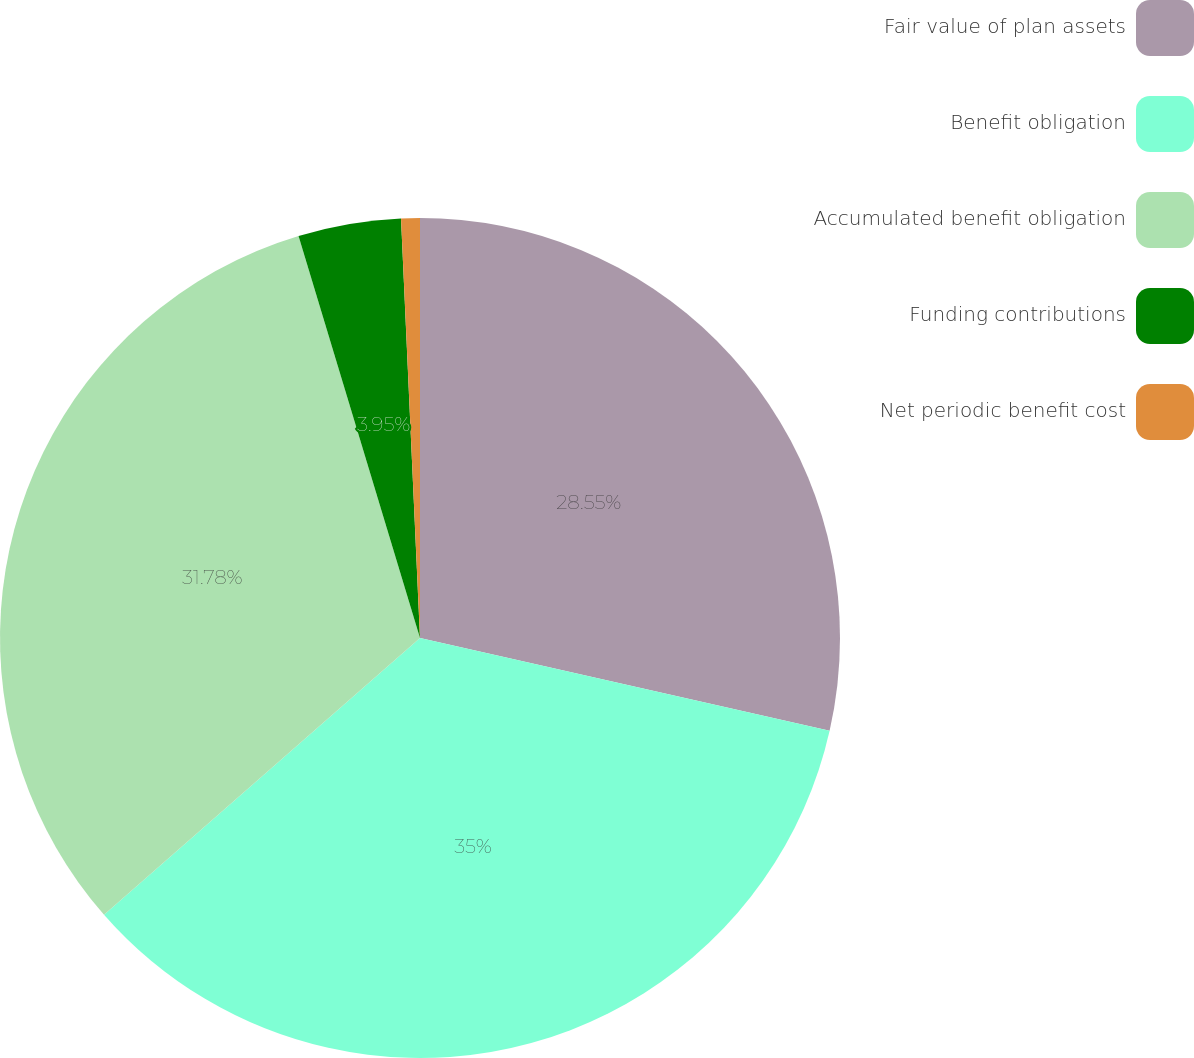<chart> <loc_0><loc_0><loc_500><loc_500><pie_chart><fcel>Fair value of plan assets<fcel>Benefit obligation<fcel>Accumulated benefit obligation<fcel>Funding contributions<fcel>Net periodic benefit cost<nl><fcel>28.55%<fcel>35.01%<fcel>31.78%<fcel>3.95%<fcel>0.72%<nl></chart> 